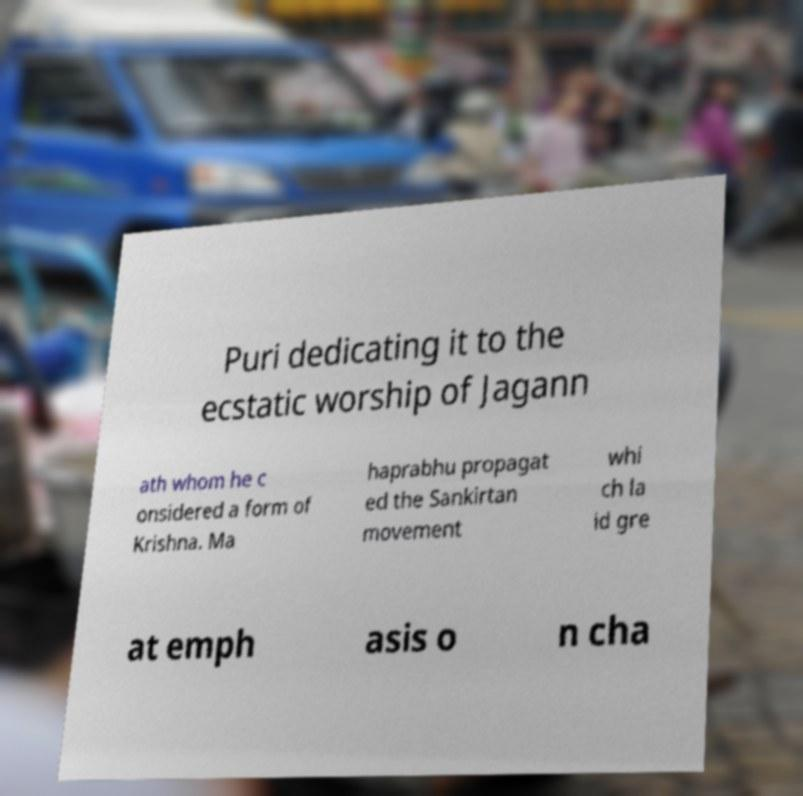Could you extract and type out the text from this image? Puri dedicating it to the ecstatic worship of Jagann ath whom he c onsidered a form of Krishna. Ma haprabhu propagat ed the Sankirtan movement whi ch la id gre at emph asis o n cha 